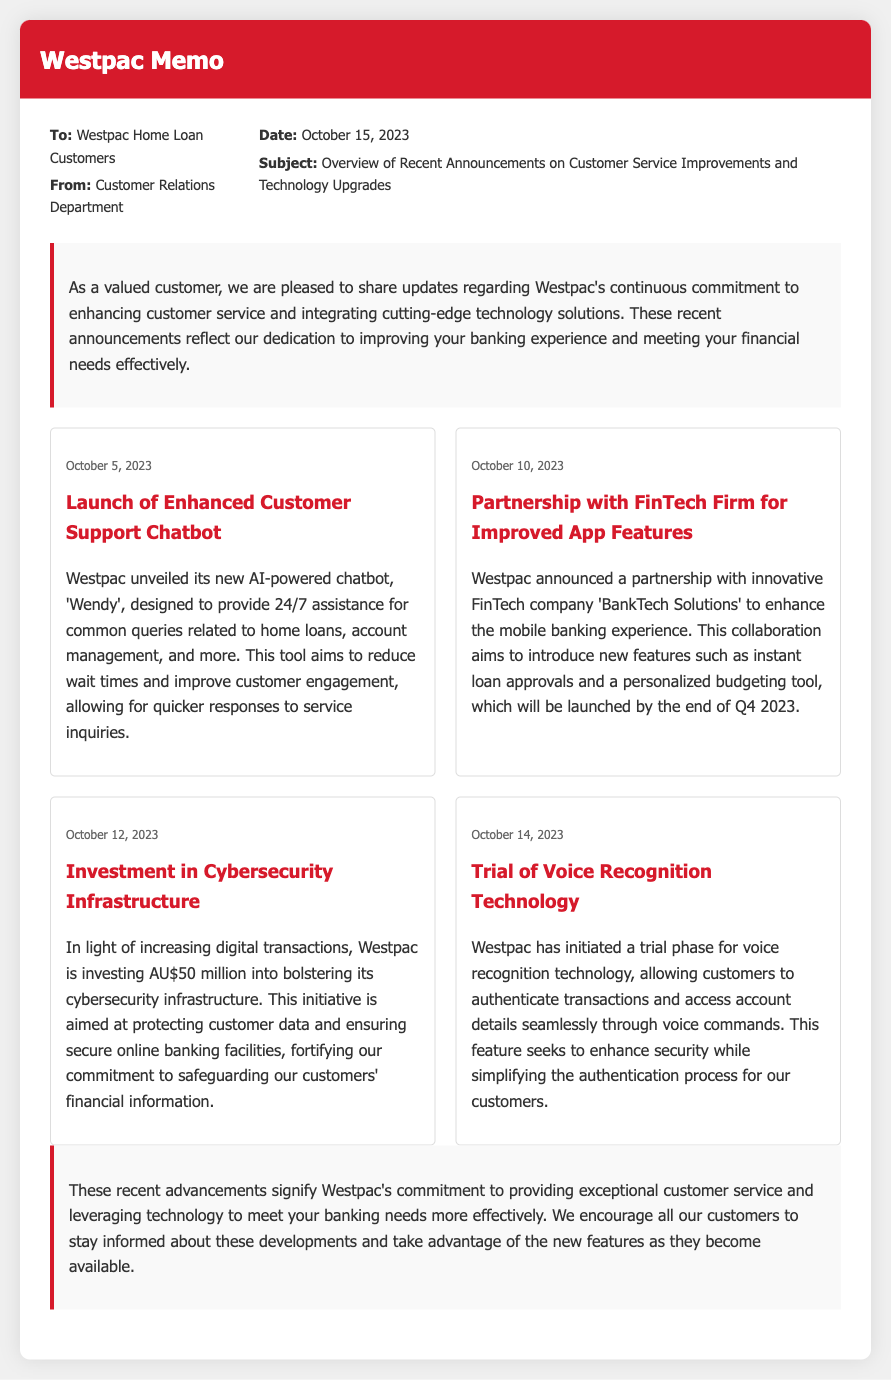What is the date of the memo? The memo is dated October 15, 2023, as indicated in the header of the document.
Answer: October 15, 2023 Who is the new AI-powered chatbot named? The memo mentions the new AI-powered chatbot is named 'Wendy'.
Answer: Wendy What is the amount invested in cybersecurity infrastructure? The document specifies that Westpac is investing AU$50 million into its cybersecurity infrastructure.
Answer: AU$50 million What new feature will the partnership with 'BankTech Solutions' provide? The partnership aims to introduce new features such as instant loan approvals and a personalized budgeting tool.
Answer: Instant loan approvals When was the chatbot 'Wendy' launched? The launch of the enhanced customer support chatbot occurred on October 5, 2023, based on the announcement date provided.
Answer: October 5, 2023 What is the primary purpose of the voice recognition technology trial? The trial of voice recognition technology seeks to enhance security while simplifying the authentication process for customers.
Answer: Enhance security What  does "Customer Relations Department" represent in this memo? This indicates the department responsible for creating the memo, providing customer updates and information.
Answer: Customer Relations Department What date will the mobile banking features be launched? The new features from the partnership with 'BankTech Solutions' are expected to be launched by the end of Q4 2023.
Answer: End of Q4 2023 